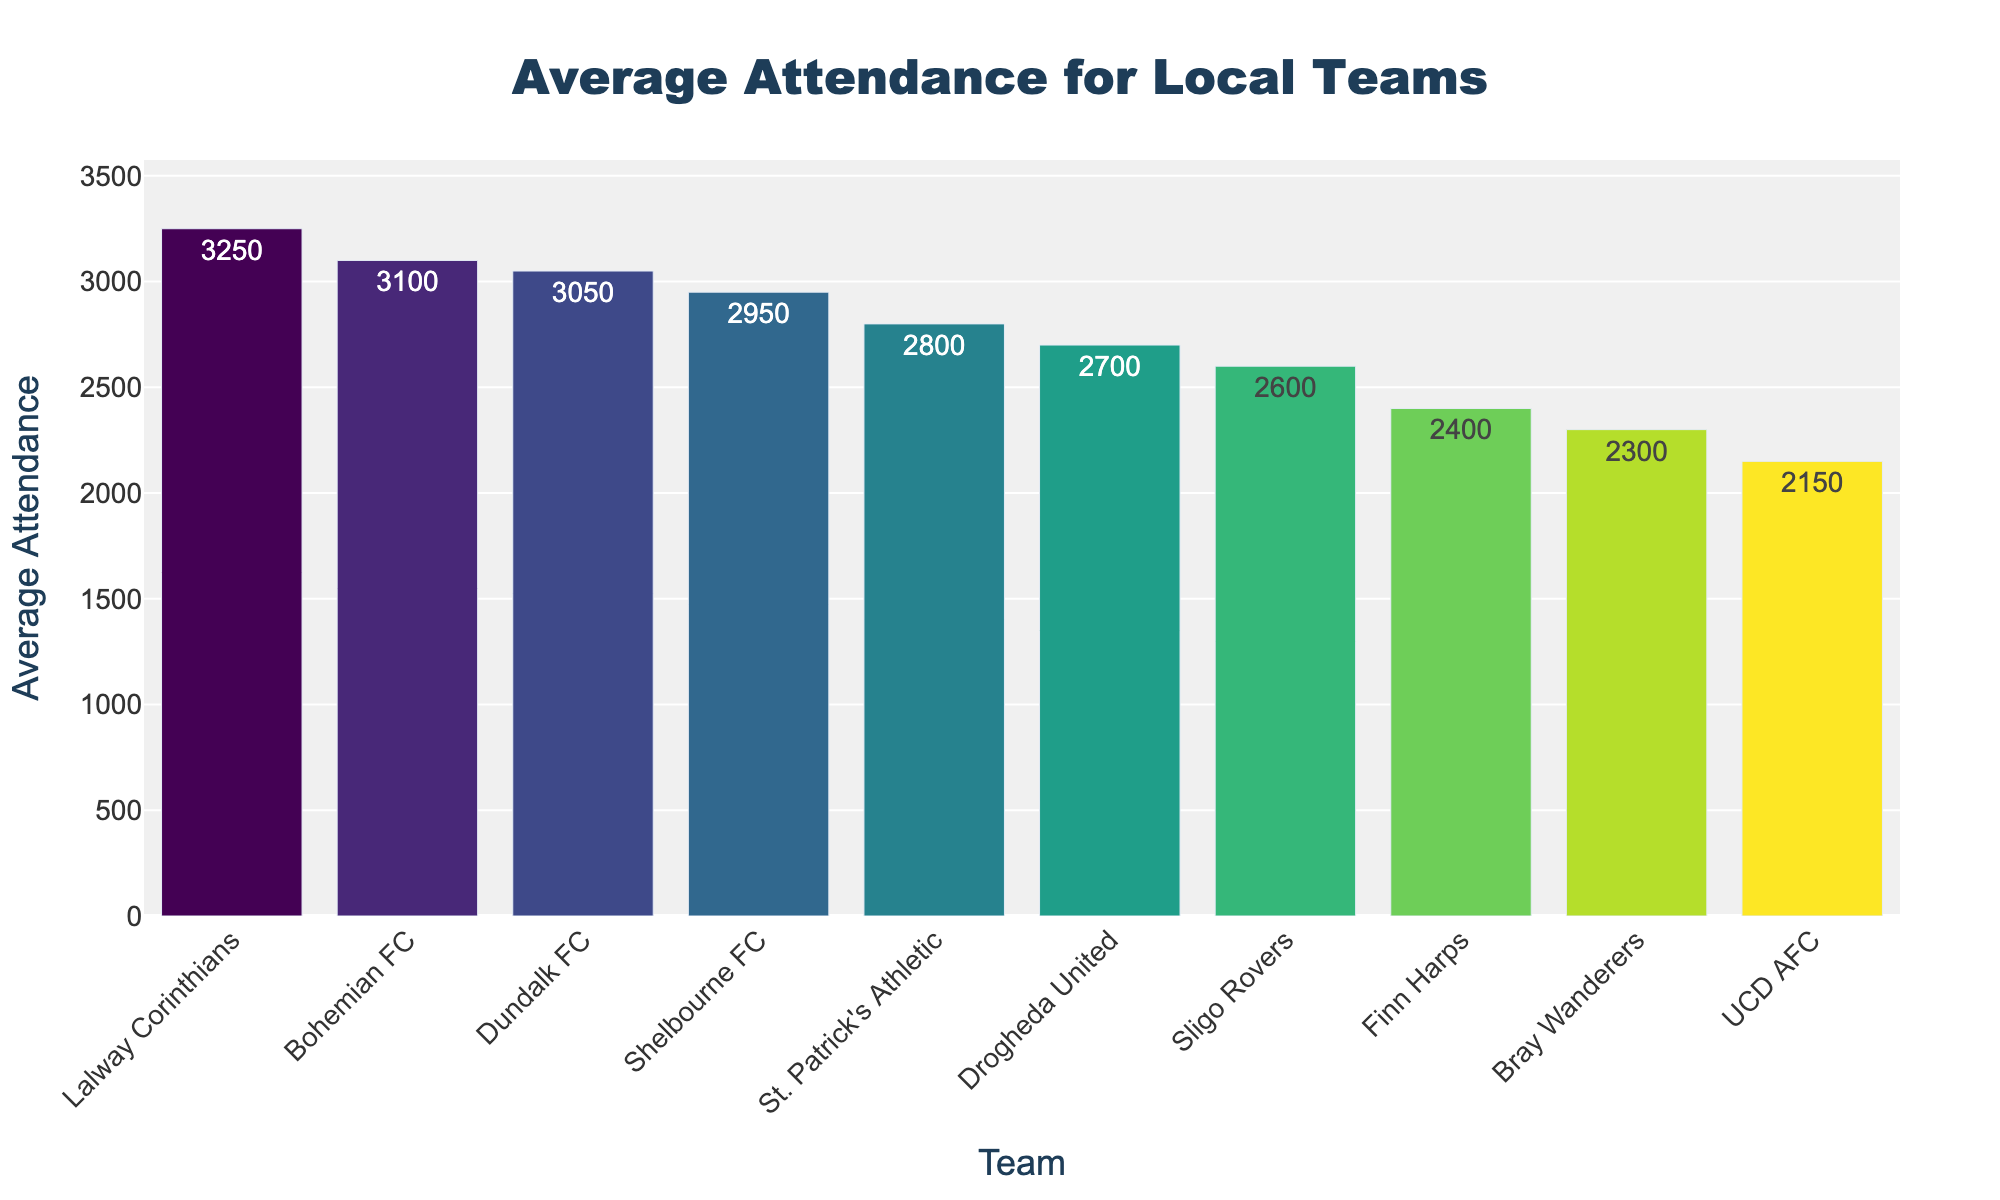Which team has the highest average attendance? By observing the heights of the bars, the tallest bar represents the team with the highest average attendance. Lalway Corinthians has the highest bar.
Answer: Lalway Corinthians Which team has the lowest average attendance? By observing the heights of the bars, the shortest bar represents the team with the lowest average attendance. UCD AFC has the shortest bar.
Answer: UCD AFC How much higher is Lalway Corinthians' average attendance compared to Bray Wanderers'? Lalway Corinthians has an average attendance of 3250, and Bray Wanderers have 2300. The difference is 3250 - 2300.
Answer: 950 What's the combined average attendance of the top three teams? Identify the top three teams by their bar heights: Lalway Corinthians (3250), Bohemian FC (3100), and Dundalk FC (3050). Sum these values: 3250 + 3100 + 3050.
Answer: 9400 Which teams have an average attendance between 2500 and 3000? Identify the teams with bars of height between 2500 and 3000. Shelbourne FC (2950), Drogheda United (2700), and Sligo Rovers (2600) meet this criterion.
Answer: Shelbourne FC, Drogheda United, Sligo Rovers Is Bohemian FC's average attendance more than twice that of UCD AFC? Bohemian FC has an average attendance of 3100. UCD AFC has 2150. Calculate if 3100 > 2 * 2150. Since 3100 < 4300, the answer is no.
Answer: No What is the average attendance of the teams with less than 3000 attendees? Teams with less than 3000 average attendance are Shelbourne FC (2950), Dundalk FC (3050), Drogheda United (2700), Sligo Rovers (2600), Finn Harps (2400), Bray Wanderers (2300), and UCD AFC (2150). Sum these values and divide by the number of teams: (2950 + 2700 + 2600 + 2400 + 2300 + 2150) / 6.
Answer: 2517 Rank the teams by average attendance from highest to lowest. List the teams in order of bar height, tallest to shortest: Lalway Corinthians (3250), Bohemian FC (3100), Dundalk FC (3050), St. Patrick's Athletic (2800), Shelbourne FC (2950), Drogheda United (2700), Sligo Rovers (2600), Finn Harps (2400), Bray Wanderers (2300), UCD AFC (2150).
Answer: Lalway Corinthians, Bohemian FC, Dundalk FC, Shelbourne FC, St. Patrick's Athletic, Drogheda United, Sligo Rovers, Finn Harps, Bray Wanderers, UCD AFC 